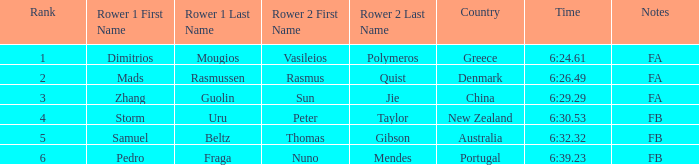What is the names of the rowers that the time was 6:24.61? Dimitrios Mougios , Vasileios Polymeros. 